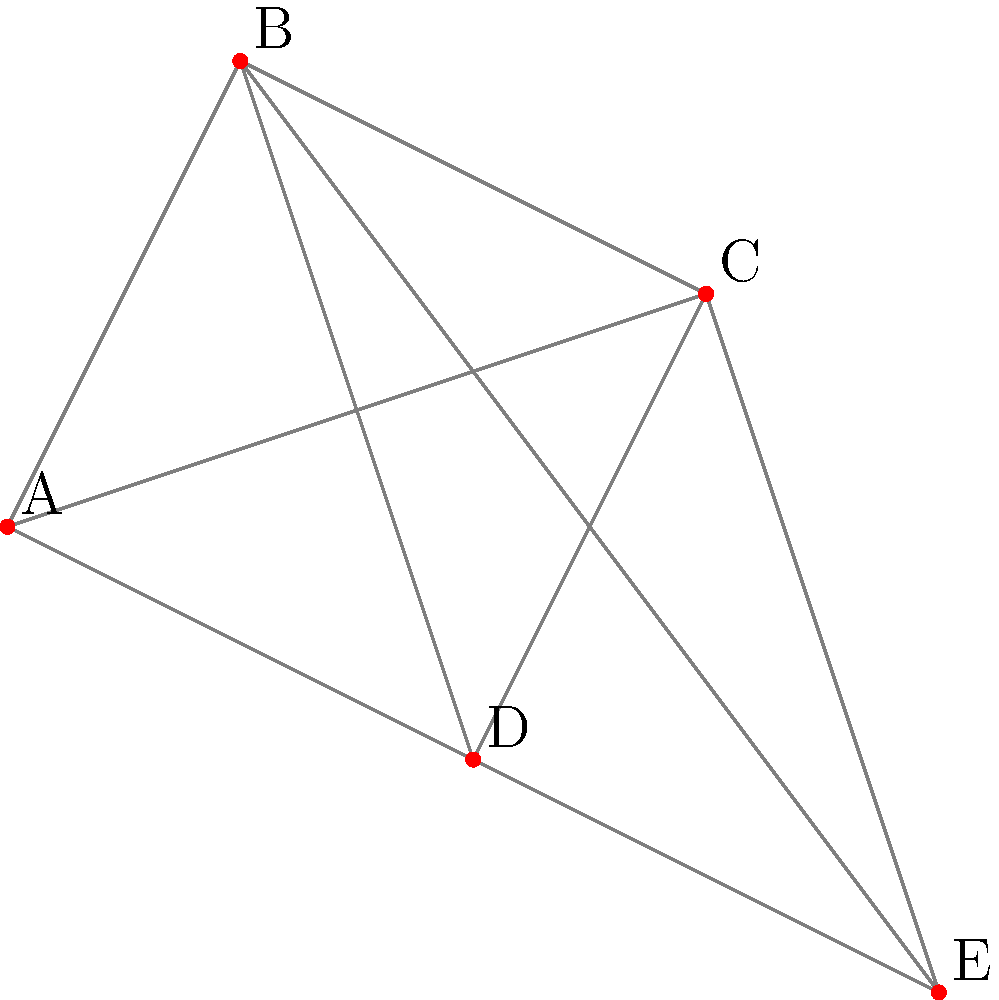As the organizer of a classic car rally, you need to plan the most efficient route through five cities (A, B, C, D, and E) represented in the graph above. Each line represents a road connecting two cities. What is the minimum number of roads that must be traveled to visit all five cities exactly once and return to the starting point? To solve this problem, we need to apply the concept of a Hamiltonian cycle in graph theory. A Hamiltonian cycle is a path in an undirected graph that visits each vertex exactly once and returns to the starting vertex.

Step 1: Observe that the graph is complete, meaning every city is directly connected to every other city.

Step 2: In a complete graph with $n$ vertices, a Hamiltonian cycle always exists and uses exactly $n$ edges.

Step 3: Count the number of cities (vertices) in the graph:
A, B, C, D, and E - there are 5 cities in total.

Step 4: Since we have a complete graph with 5 vertices, the Hamiltonian cycle will consist of 5 edges.

Step 5: Verify that this solution satisfies the conditions:
- Each city is visited exactly once
- The path returns to the starting point
- The number of roads (edges) used is minimal

Therefore, the minimum number of roads that must be traveled to visit all five cities exactly once and return to the starting point is 5.
Answer: 5 roads 